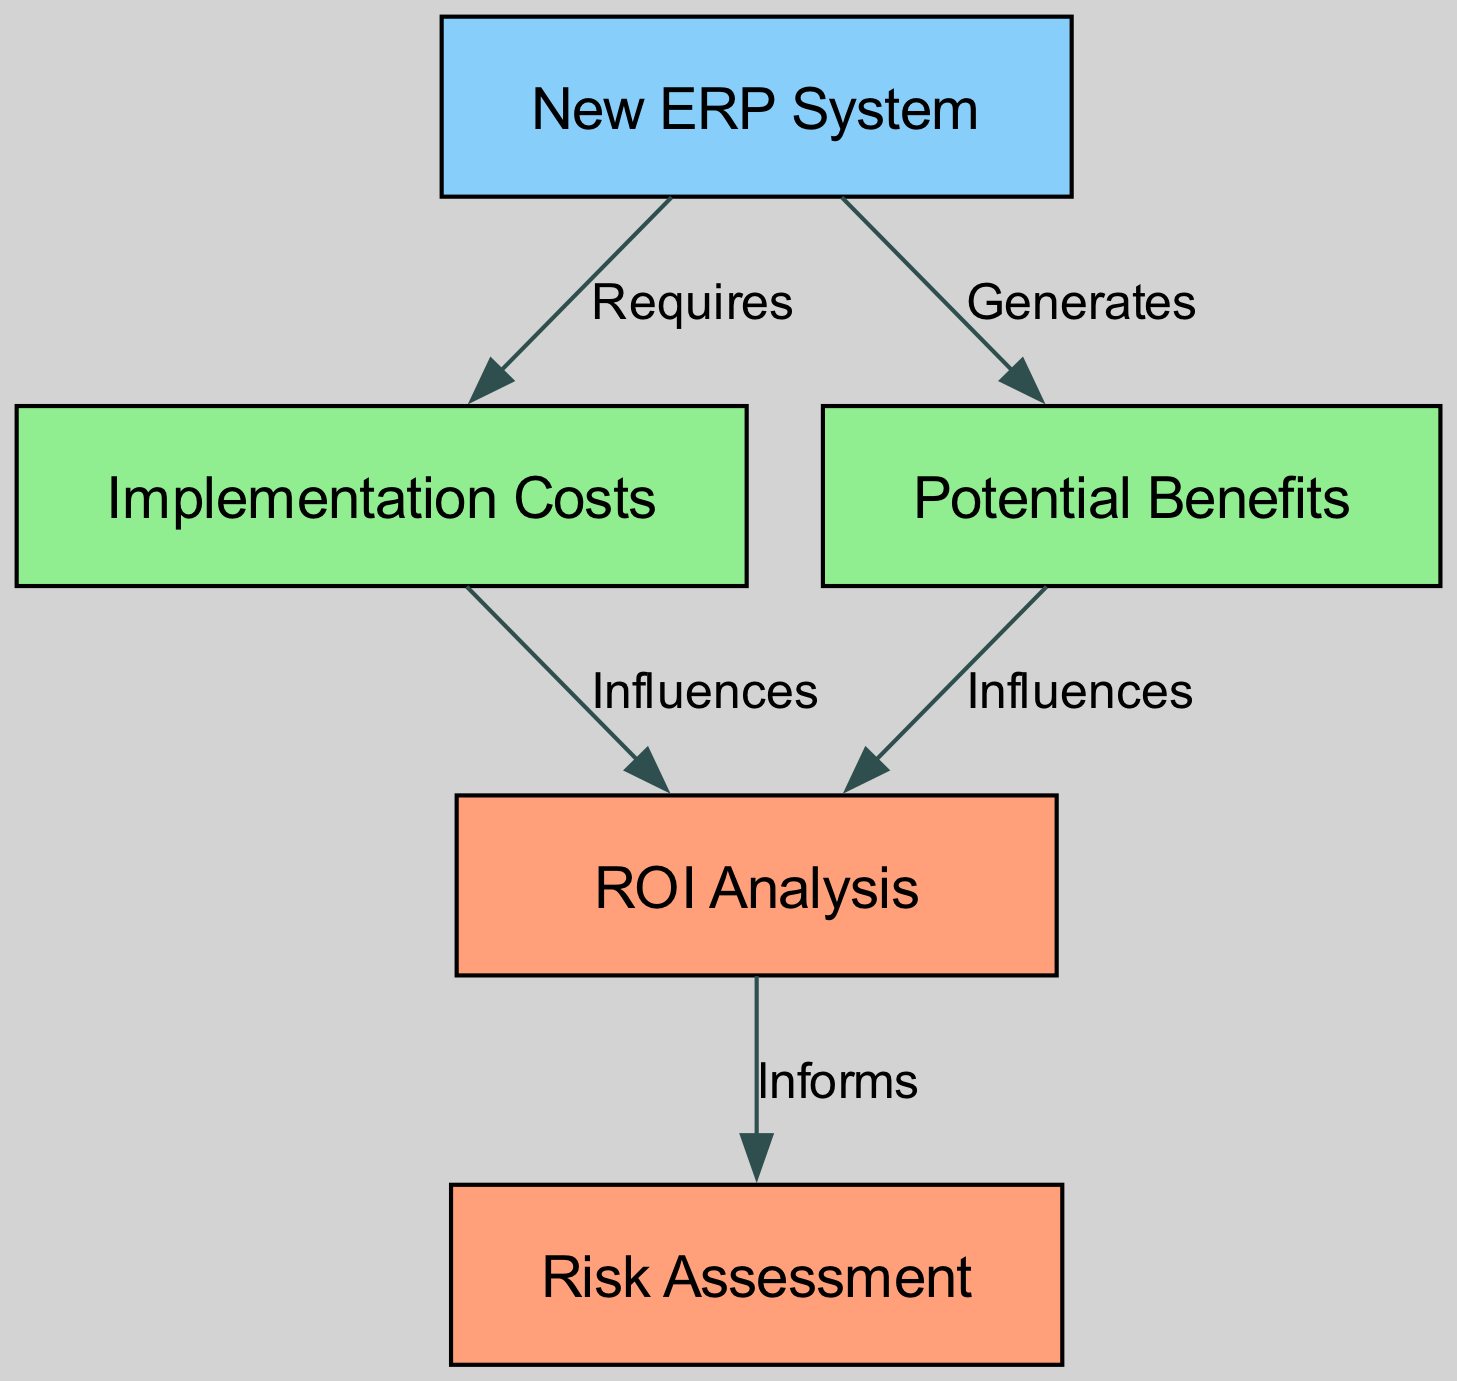What is the label of node 1? Node 1 is labeled "New ERP System", as indicated in the diagram.
Answer: New ERP System How many nodes are in the diagram? The diagram contains five distinct nodes: New ERP System, Implementation Costs, Potential Benefits, ROI Analysis, and Risk Assessment.
Answer: 5 What is the relationship between node 1 and node 2? Node 1, the New ERP System, requires node 2, which represents Implementation Costs, as shown by the edge labeled "Requires" connecting them.
Answer: Requires Which node generates potential benefits? Node 1, labeled "New ERP System", generates the potential benefits as indicated by the edge connecting it to node 3.
Answer: New ERP System What does node 4 inform? Node 4, titled "ROI Analysis," informs the "Risk Assessment" in node 5 according to the edge labeled "Informs."
Answer: Risk Assessment Which elements influence ROI Analysis? Both Implementation Costs (node 2) and Potential Benefits (node 3) influence ROI Analysis (node 4), as shown by the edges connecting these nodes to node 4.
Answer: Implementation Costs and Potential Benefits What color represents node 3? Node 3, labeled "Potential Benefits", is colored light green in the diagram.
Answer: Light green Which node has the highest level of influence on risk assessment? Node 4, "ROI Analysis," has the highest level of influence on node 5, "Risk Assessment," as it directly informs it.
Answer: ROI Analysis 